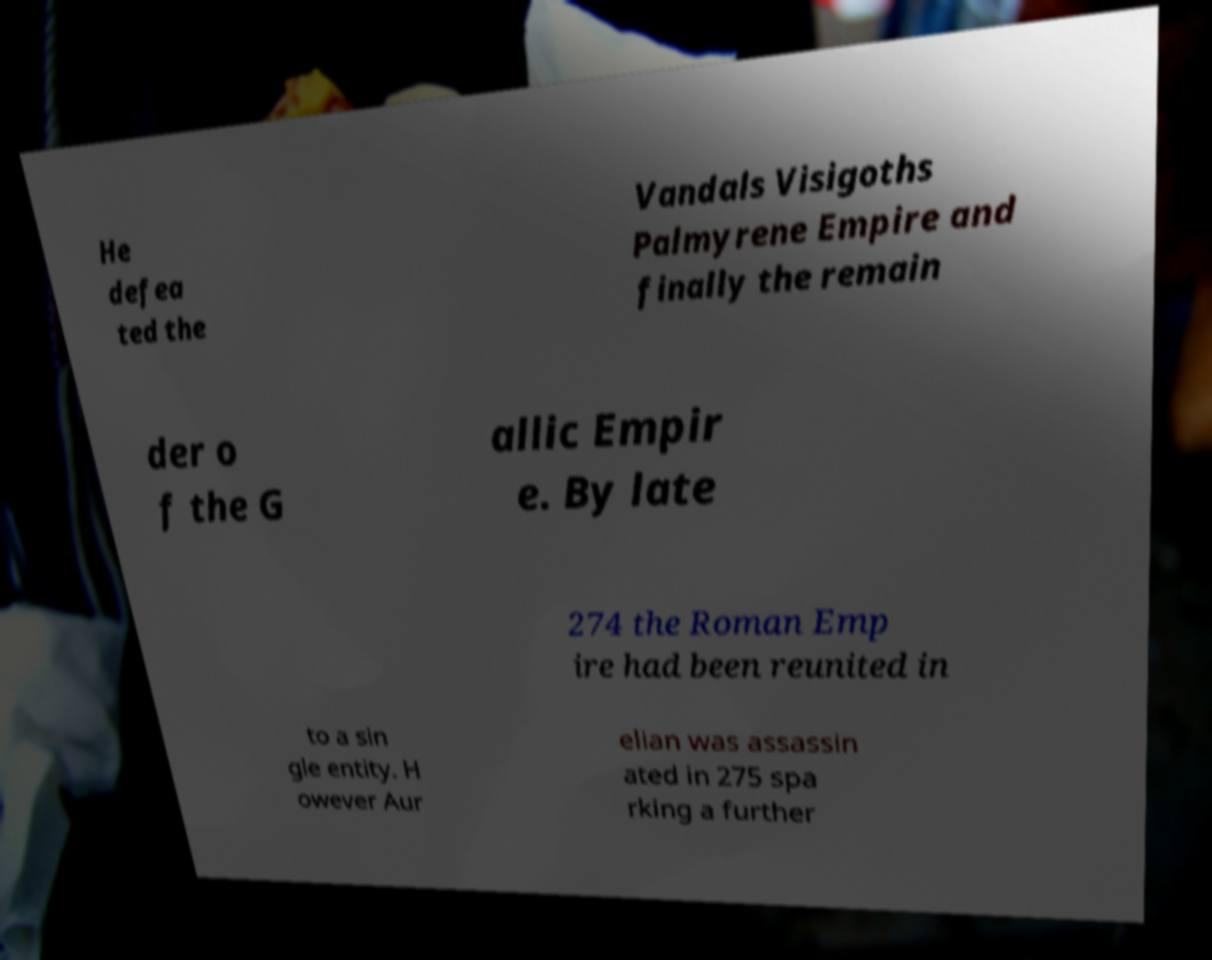There's text embedded in this image that I need extracted. Can you transcribe it verbatim? He defea ted the Vandals Visigoths Palmyrene Empire and finally the remain der o f the G allic Empir e. By late 274 the Roman Emp ire had been reunited in to a sin gle entity. H owever Aur elian was assassin ated in 275 spa rking a further 